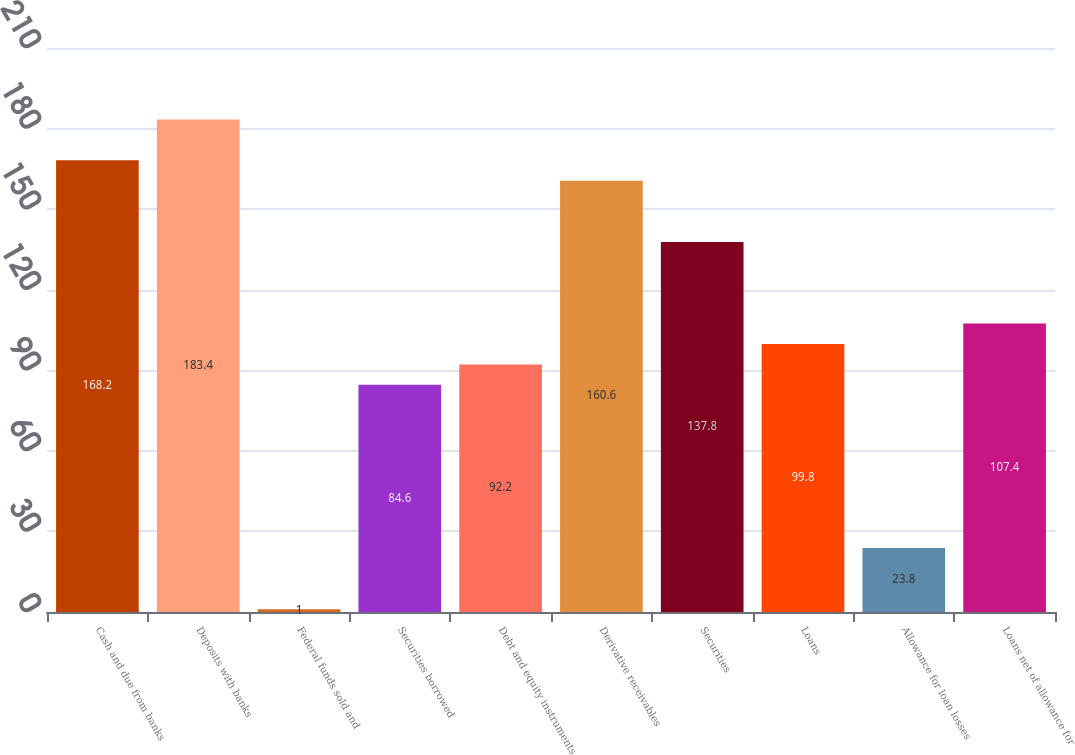<chart> <loc_0><loc_0><loc_500><loc_500><bar_chart><fcel>Cash and due from banks<fcel>Deposits with banks<fcel>Federal funds sold and<fcel>Securities borrowed<fcel>Debt and equity instruments<fcel>Derivative receivables<fcel>Securities<fcel>Loans<fcel>Allowance for loan losses<fcel>Loans net of allowance for<nl><fcel>168.2<fcel>183.4<fcel>1<fcel>84.6<fcel>92.2<fcel>160.6<fcel>137.8<fcel>99.8<fcel>23.8<fcel>107.4<nl></chart> 